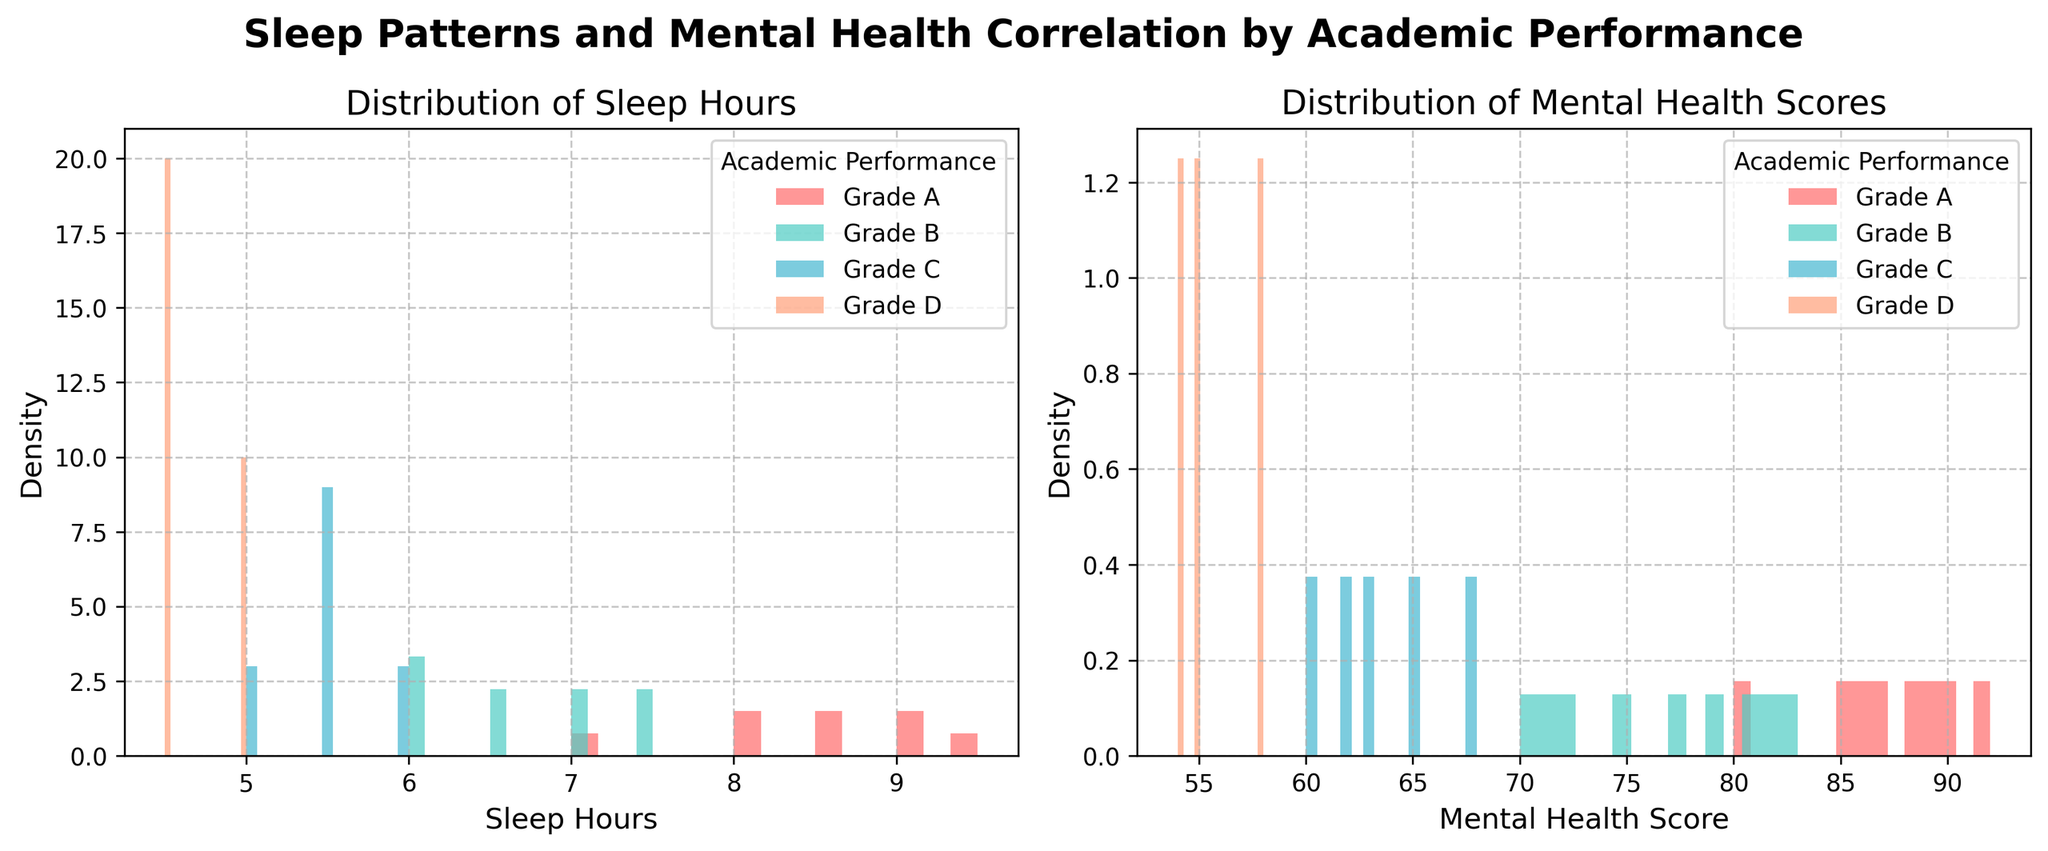What's the title of the figure? The title is placed at the top center of the figure and states the main subject.
Answer: Sleep Patterns and Mental Health Correlation by Academic Performance What are the labels on the x-axis and y-axis of the left plot? The labels on the x-axis of the left plot denote 'Sleep Hours', and the y-axis label denotes 'Density'.
Answer: Sleep Hours, Density Which academic performance grade has the widest spread of sleep hours in the left plot? To find the widest spread, look at the range of sleep hours where the density curves appear. Grade D seems to have a wider spread across sleep hours.
Answer: Grade D Which grade appears to have the highest density peak in mental health scores? In the right plot, observe which density curve has the tallest peak to determine higher density. Grade A has the highest density peak in mental health scores.
Answer: Grade A Which academic performance grade has the lowest density peak for sleep hours? Identify the shortest peak in the left plot corresponding to the grades' sleep hours data. Grade D has the lowest density peak.
Answer: Grade D How do the sleep hours distributions compare among Grades A and C? Compare the two distributions' spread and peak locations in the left plot. Grade A has more consolidated sleep hours around higher values (e.g., 8-9 hours), while Grade C is more spread out lower sleep hours (e.g., 5-6 hours).
Answer: Grade A is higher and more consolidated, Grade C is lower and spread out What is the range of sleep hours that most students in Grade B have? Observe the range where the density peak for Grade B in the left plot is highest. Most Grade B students have sleep hours between roughly 6 to 7.5 hours.
Answer: 6 to 7.5 hours Does there appear to be any correlation between higher sleep hours and higher mental health scores? By comparing the shapes of peaks in both plots, particularly Grade A, which shows high sleep and mental health scores.
Answer: Yes Which academic performance grade shows the highest density in the mental health scores around 60–65? Evaluate the density peaks around the 60-65 mental health score range in the right plot. Grade C demonstrates higher density around this range.
Answer: Grade C Is there any academic performance grade that does not appear frequently in the dataset? Look for the density curves with the smallest peaks in both plots, representing fewer data points. Grade D appears infrequently.
Answer: Grade D 